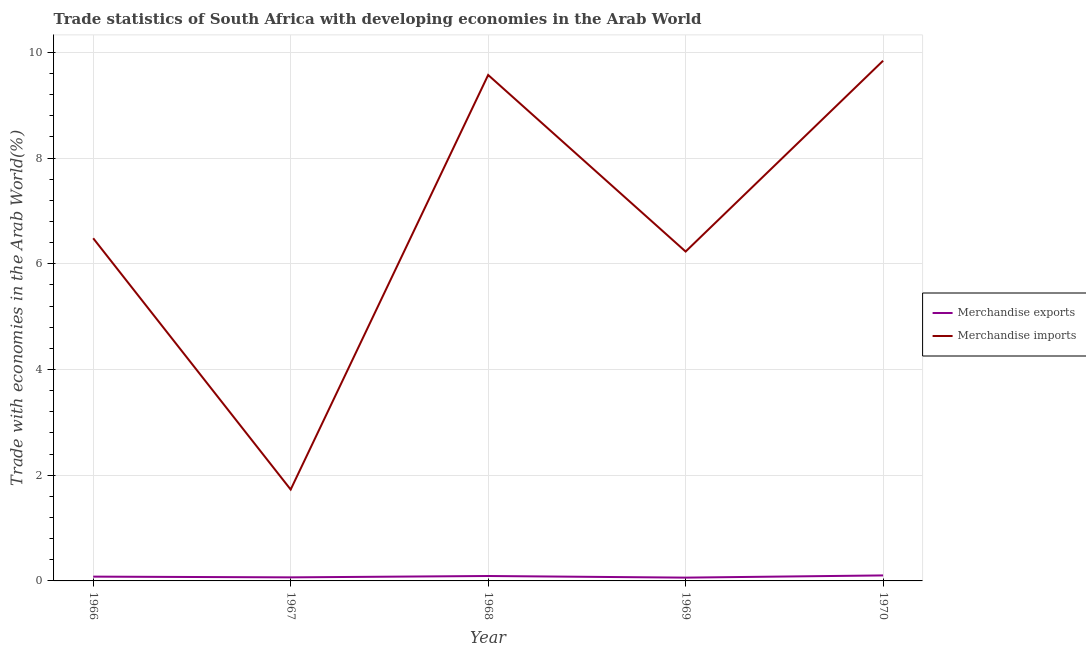Does the line corresponding to merchandise imports intersect with the line corresponding to merchandise exports?
Your response must be concise. No. Is the number of lines equal to the number of legend labels?
Offer a terse response. Yes. What is the merchandise imports in 1969?
Provide a succinct answer. 6.23. Across all years, what is the maximum merchandise exports?
Offer a terse response. 0.1. Across all years, what is the minimum merchandise imports?
Provide a succinct answer. 1.73. In which year was the merchandise exports minimum?
Make the answer very short. 1969. What is the total merchandise imports in the graph?
Provide a succinct answer. 33.86. What is the difference between the merchandise exports in 1967 and that in 1969?
Give a very brief answer. 0. What is the difference between the merchandise exports in 1967 and the merchandise imports in 1970?
Provide a succinct answer. -9.78. What is the average merchandise imports per year?
Your answer should be compact. 6.77. In the year 1970, what is the difference between the merchandise exports and merchandise imports?
Your answer should be compact. -9.74. In how many years, is the merchandise imports greater than 4 %?
Keep it short and to the point. 4. What is the ratio of the merchandise imports in 1966 to that in 1968?
Make the answer very short. 0.68. Is the difference between the merchandise imports in 1966 and 1967 greater than the difference between the merchandise exports in 1966 and 1967?
Give a very brief answer. Yes. What is the difference between the highest and the second highest merchandise imports?
Provide a short and direct response. 0.27. What is the difference between the highest and the lowest merchandise exports?
Provide a short and direct response. 0.04. In how many years, is the merchandise exports greater than the average merchandise exports taken over all years?
Make the answer very short. 2. Is the merchandise imports strictly greater than the merchandise exports over the years?
Ensure brevity in your answer.  Yes. Is the merchandise exports strictly less than the merchandise imports over the years?
Provide a succinct answer. Yes. How many years are there in the graph?
Offer a very short reply. 5. What is the difference between two consecutive major ticks on the Y-axis?
Your answer should be very brief. 2. Does the graph contain any zero values?
Provide a short and direct response. No. Where does the legend appear in the graph?
Your answer should be compact. Center right. What is the title of the graph?
Ensure brevity in your answer.  Trade statistics of South Africa with developing economies in the Arab World. Does "Diesel" appear as one of the legend labels in the graph?
Offer a terse response. No. What is the label or title of the X-axis?
Your response must be concise. Year. What is the label or title of the Y-axis?
Offer a very short reply. Trade with economies in the Arab World(%). What is the Trade with economies in the Arab World(%) in Merchandise exports in 1966?
Your response must be concise. 0.08. What is the Trade with economies in the Arab World(%) of Merchandise imports in 1966?
Your answer should be very brief. 6.48. What is the Trade with economies in the Arab World(%) of Merchandise exports in 1967?
Ensure brevity in your answer.  0.07. What is the Trade with economies in the Arab World(%) in Merchandise imports in 1967?
Keep it short and to the point. 1.73. What is the Trade with economies in the Arab World(%) of Merchandise exports in 1968?
Keep it short and to the point. 0.09. What is the Trade with economies in the Arab World(%) of Merchandise imports in 1968?
Your answer should be very brief. 9.57. What is the Trade with economies in the Arab World(%) of Merchandise exports in 1969?
Ensure brevity in your answer.  0.06. What is the Trade with economies in the Arab World(%) of Merchandise imports in 1969?
Your answer should be compact. 6.23. What is the Trade with economies in the Arab World(%) of Merchandise exports in 1970?
Your response must be concise. 0.1. What is the Trade with economies in the Arab World(%) in Merchandise imports in 1970?
Make the answer very short. 9.84. Across all years, what is the maximum Trade with economies in the Arab World(%) in Merchandise exports?
Provide a short and direct response. 0.1. Across all years, what is the maximum Trade with economies in the Arab World(%) of Merchandise imports?
Your answer should be very brief. 9.84. Across all years, what is the minimum Trade with economies in the Arab World(%) in Merchandise exports?
Offer a terse response. 0.06. Across all years, what is the minimum Trade with economies in the Arab World(%) in Merchandise imports?
Your answer should be compact. 1.73. What is the total Trade with economies in the Arab World(%) in Merchandise exports in the graph?
Make the answer very short. 0.41. What is the total Trade with economies in the Arab World(%) in Merchandise imports in the graph?
Your answer should be compact. 33.86. What is the difference between the Trade with economies in the Arab World(%) in Merchandise exports in 1966 and that in 1967?
Give a very brief answer. 0.01. What is the difference between the Trade with economies in the Arab World(%) of Merchandise imports in 1966 and that in 1967?
Your response must be concise. 4.75. What is the difference between the Trade with economies in the Arab World(%) in Merchandise exports in 1966 and that in 1968?
Offer a very short reply. -0.01. What is the difference between the Trade with economies in the Arab World(%) of Merchandise imports in 1966 and that in 1968?
Provide a short and direct response. -3.09. What is the difference between the Trade with economies in the Arab World(%) of Merchandise exports in 1966 and that in 1969?
Your response must be concise. 0.02. What is the difference between the Trade with economies in the Arab World(%) of Merchandise imports in 1966 and that in 1969?
Provide a succinct answer. 0.25. What is the difference between the Trade with economies in the Arab World(%) of Merchandise exports in 1966 and that in 1970?
Make the answer very short. -0.02. What is the difference between the Trade with economies in the Arab World(%) of Merchandise imports in 1966 and that in 1970?
Your answer should be compact. -3.36. What is the difference between the Trade with economies in the Arab World(%) of Merchandise exports in 1967 and that in 1968?
Provide a succinct answer. -0.03. What is the difference between the Trade with economies in the Arab World(%) of Merchandise imports in 1967 and that in 1968?
Provide a short and direct response. -7.84. What is the difference between the Trade with economies in the Arab World(%) of Merchandise exports in 1967 and that in 1969?
Provide a short and direct response. 0.01. What is the difference between the Trade with economies in the Arab World(%) of Merchandise imports in 1967 and that in 1969?
Ensure brevity in your answer.  -4.5. What is the difference between the Trade with economies in the Arab World(%) in Merchandise exports in 1967 and that in 1970?
Your answer should be compact. -0.04. What is the difference between the Trade with economies in the Arab World(%) of Merchandise imports in 1967 and that in 1970?
Offer a very short reply. -8.11. What is the difference between the Trade with economies in the Arab World(%) in Merchandise exports in 1968 and that in 1969?
Ensure brevity in your answer.  0.03. What is the difference between the Trade with economies in the Arab World(%) of Merchandise imports in 1968 and that in 1969?
Your response must be concise. 3.34. What is the difference between the Trade with economies in the Arab World(%) in Merchandise exports in 1968 and that in 1970?
Provide a short and direct response. -0.01. What is the difference between the Trade with economies in the Arab World(%) in Merchandise imports in 1968 and that in 1970?
Ensure brevity in your answer.  -0.27. What is the difference between the Trade with economies in the Arab World(%) in Merchandise exports in 1969 and that in 1970?
Provide a short and direct response. -0.04. What is the difference between the Trade with economies in the Arab World(%) of Merchandise imports in 1969 and that in 1970?
Your answer should be compact. -3.61. What is the difference between the Trade with economies in the Arab World(%) of Merchandise exports in 1966 and the Trade with economies in the Arab World(%) of Merchandise imports in 1967?
Ensure brevity in your answer.  -1.65. What is the difference between the Trade with economies in the Arab World(%) in Merchandise exports in 1966 and the Trade with economies in the Arab World(%) in Merchandise imports in 1968?
Keep it short and to the point. -9.49. What is the difference between the Trade with economies in the Arab World(%) of Merchandise exports in 1966 and the Trade with economies in the Arab World(%) of Merchandise imports in 1969?
Ensure brevity in your answer.  -6.15. What is the difference between the Trade with economies in the Arab World(%) in Merchandise exports in 1966 and the Trade with economies in the Arab World(%) in Merchandise imports in 1970?
Your response must be concise. -9.76. What is the difference between the Trade with economies in the Arab World(%) in Merchandise exports in 1967 and the Trade with economies in the Arab World(%) in Merchandise imports in 1968?
Your answer should be compact. -9.51. What is the difference between the Trade with economies in the Arab World(%) in Merchandise exports in 1967 and the Trade with economies in the Arab World(%) in Merchandise imports in 1969?
Your response must be concise. -6.17. What is the difference between the Trade with economies in the Arab World(%) of Merchandise exports in 1967 and the Trade with economies in the Arab World(%) of Merchandise imports in 1970?
Your answer should be very brief. -9.78. What is the difference between the Trade with economies in the Arab World(%) of Merchandise exports in 1968 and the Trade with economies in the Arab World(%) of Merchandise imports in 1969?
Give a very brief answer. -6.14. What is the difference between the Trade with economies in the Arab World(%) of Merchandise exports in 1968 and the Trade with economies in the Arab World(%) of Merchandise imports in 1970?
Offer a terse response. -9.75. What is the difference between the Trade with economies in the Arab World(%) of Merchandise exports in 1969 and the Trade with economies in the Arab World(%) of Merchandise imports in 1970?
Keep it short and to the point. -9.78. What is the average Trade with economies in the Arab World(%) of Merchandise exports per year?
Give a very brief answer. 0.08. What is the average Trade with economies in the Arab World(%) of Merchandise imports per year?
Keep it short and to the point. 6.77. In the year 1966, what is the difference between the Trade with economies in the Arab World(%) of Merchandise exports and Trade with economies in the Arab World(%) of Merchandise imports?
Make the answer very short. -6.4. In the year 1967, what is the difference between the Trade with economies in the Arab World(%) in Merchandise exports and Trade with economies in the Arab World(%) in Merchandise imports?
Make the answer very short. -1.66. In the year 1968, what is the difference between the Trade with economies in the Arab World(%) of Merchandise exports and Trade with economies in the Arab World(%) of Merchandise imports?
Offer a terse response. -9.48. In the year 1969, what is the difference between the Trade with economies in the Arab World(%) in Merchandise exports and Trade with economies in the Arab World(%) in Merchandise imports?
Your response must be concise. -6.17. In the year 1970, what is the difference between the Trade with economies in the Arab World(%) of Merchandise exports and Trade with economies in the Arab World(%) of Merchandise imports?
Your answer should be very brief. -9.74. What is the ratio of the Trade with economies in the Arab World(%) of Merchandise exports in 1966 to that in 1967?
Provide a short and direct response. 1.21. What is the ratio of the Trade with economies in the Arab World(%) of Merchandise imports in 1966 to that in 1967?
Offer a terse response. 3.75. What is the ratio of the Trade with economies in the Arab World(%) of Merchandise exports in 1966 to that in 1968?
Keep it short and to the point. 0.87. What is the ratio of the Trade with economies in the Arab World(%) in Merchandise imports in 1966 to that in 1968?
Provide a short and direct response. 0.68. What is the ratio of the Trade with economies in the Arab World(%) of Merchandise exports in 1966 to that in 1969?
Your answer should be compact. 1.3. What is the ratio of the Trade with economies in the Arab World(%) of Merchandise imports in 1966 to that in 1969?
Make the answer very short. 1.04. What is the ratio of the Trade with economies in the Arab World(%) of Merchandise exports in 1966 to that in 1970?
Offer a very short reply. 0.78. What is the ratio of the Trade with economies in the Arab World(%) in Merchandise imports in 1966 to that in 1970?
Offer a terse response. 0.66. What is the ratio of the Trade with economies in the Arab World(%) in Merchandise exports in 1967 to that in 1968?
Provide a succinct answer. 0.72. What is the ratio of the Trade with economies in the Arab World(%) in Merchandise imports in 1967 to that in 1968?
Your answer should be very brief. 0.18. What is the ratio of the Trade with economies in the Arab World(%) in Merchandise exports in 1967 to that in 1969?
Provide a succinct answer. 1.08. What is the ratio of the Trade with economies in the Arab World(%) of Merchandise imports in 1967 to that in 1969?
Give a very brief answer. 0.28. What is the ratio of the Trade with economies in the Arab World(%) of Merchandise exports in 1967 to that in 1970?
Make the answer very short. 0.65. What is the ratio of the Trade with economies in the Arab World(%) of Merchandise imports in 1967 to that in 1970?
Offer a very short reply. 0.18. What is the ratio of the Trade with economies in the Arab World(%) of Merchandise exports in 1968 to that in 1969?
Keep it short and to the point. 1.49. What is the ratio of the Trade with economies in the Arab World(%) in Merchandise imports in 1968 to that in 1969?
Ensure brevity in your answer.  1.54. What is the ratio of the Trade with economies in the Arab World(%) of Merchandise exports in 1968 to that in 1970?
Your answer should be very brief. 0.89. What is the ratio of the Trade with economies in the Arab World(%) in Merchandise imports in 1968 to that in 1970?
Your answer should be very brief. 0.97. What is the ratio of the Trade with economies in the Arab World(%) of Merchandise exports in 1969 to that in 1970?
Your response must be concise. 0.6. What is the ratio of the Trade with economies in the Arab World(%) of Merchandise imports in 1969 to that in 1970?
Your answer should be very brief. 0.63. What is the difference between the highest and the second highest Trade with economies in the Arab World(%) of Merchandise exports?
Your answer should be very brief. 0.01. What is the difference between the highest and the second highest Trade with economies in the Arab World(%) in Merchandise imports?
Offer a very short reply. 0.27. What is the difference between the highest and the lowest Trade with economies in the Arab World(%) of Merchandise exports?
Provide a short and direct response. 0.04. What is the difference between the highest and the lowest Trade with economies in the Arab World(%) of Merchandise imports?
Make the answer very short. 8.11. 